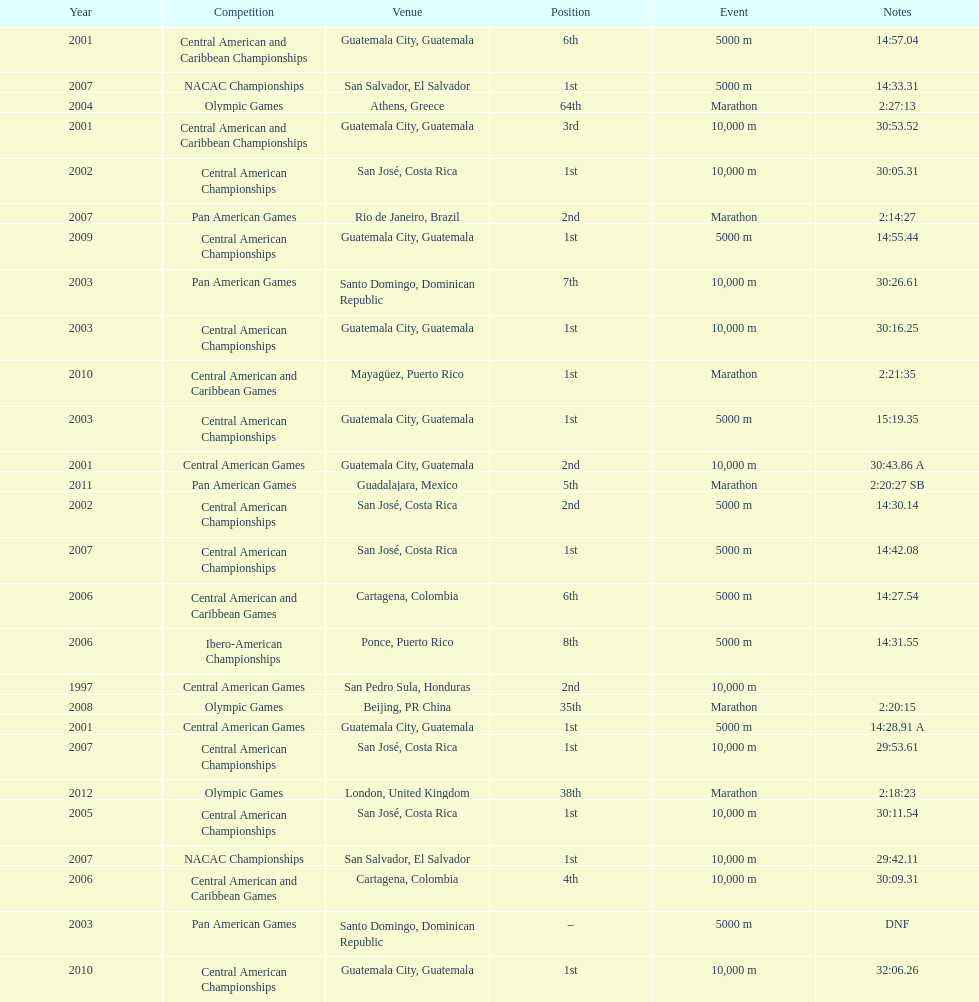Where was the only 64th position held? Athens, Greece. 